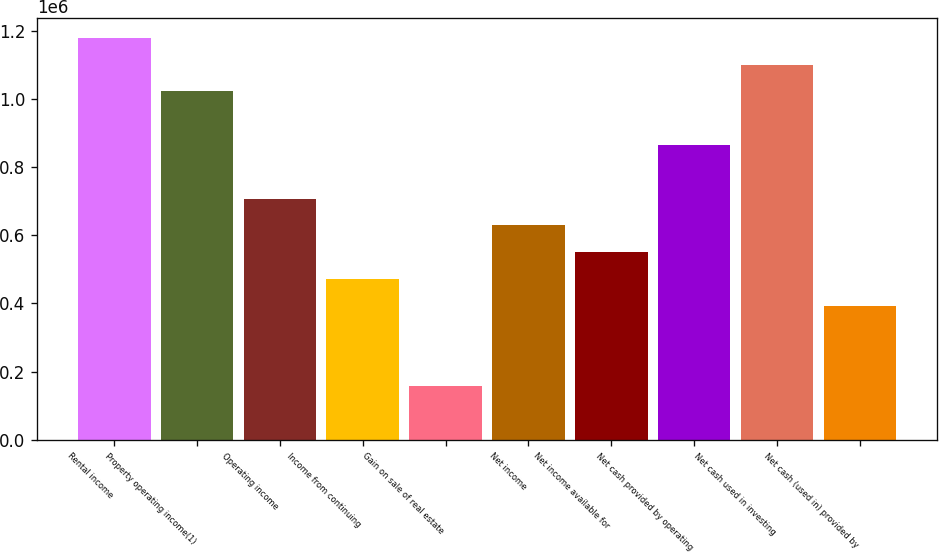<chart> <loc_0><loc_0><loc_500><loc_500><bar_chart><fcel>Rental income<fcel>Property operating income(1)<fcel>Operating income<fcel>Income from continuing<fcel>Gain on sale of real estate<fcel>Net income<fcel>Net income available for<fcel>Net cash provided by operating<fcel>Net cash used in investing<fcel>Net cash (used in) provided by<nl><fcel>1.17987e+06<fcel>1.02256e+06<fcel>707925<fcel>471951<fcel>157319<fcel>629267<fcel>550609<fcel>865241<fcel>1.10121e+06<fcel>393293<nl></chart> 